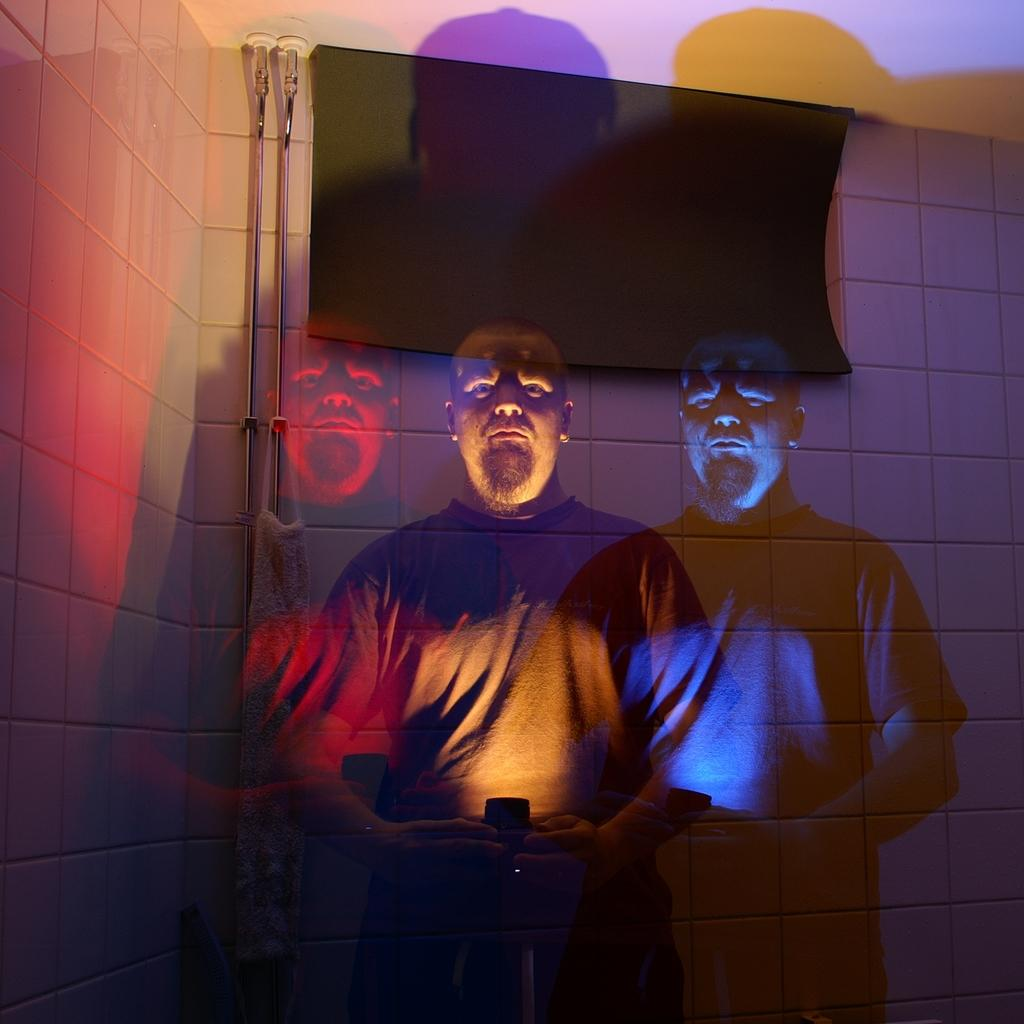Who is present in the image? There is a man in the image. What can be seen in the background of the image? There is a screen and a wall in the background of the image. What type of match is being played on the screen in the image? There is no match being played on the screen in the image; it is not mentioned in the provided facts. 